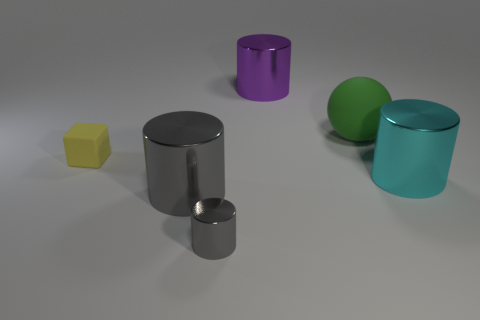Are there any other things that are the same shape as the big green thing?
Make the answer very short. No. Do the matte object that is to the left of the purple metal cylinder and the large purple shiny object have the same size?
Make the answer very short. No. What material is the tiny thing behind the large metallic cylinder to the right of the metallic thing behind the big green thing made of?
Offer a very short reply. Rubber. There is a big thing on the left side of the big purple cylinder; is it the same color as the tiny object in front of the cyan shiny object?
Provide a short and direct response. Yes. There is a large cylinder that is behind the object that is to the right of the green ball; what is it made of?
Ensure brevity in your answer.  Metal. What color is the sphere that is the same size as the cyan object?
Provide a short and direct response. Green. Do the tiny gray metal thing and the large metal thing that is right of the green thing have the same shape?
Your answer should be very brief. Yes. What is the shape of the big thing that is the same color as the small metallic object?
Offer a terse response. Cylinder. What number of big cyan shiny cylinders are behind the gray metal cylinder in front of the large metal thing that is in front of the big cyan object?
Ensure brevity in your answer.  1. There is a cylinder behind the tiny object behind the small gray shiny cylinder; what size is it?
Your answer should be very brief. Large. 